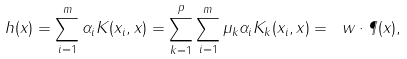<formula> <loc_0><loc_0><loc_500><loc_500>h ( x ) = \sum _ { i = 1 } ^ { m } \alpha _ { i } K ( x _ { i } , x ) = \sum _ { k = 1 } ^ { p } \sum _ { i = 1 } ^ { m } \mu _ { k } \alpha _ { i } K _ { k } ( x _ { i } , x ) = \ w \cdot \P ( x ) ,</formula> 